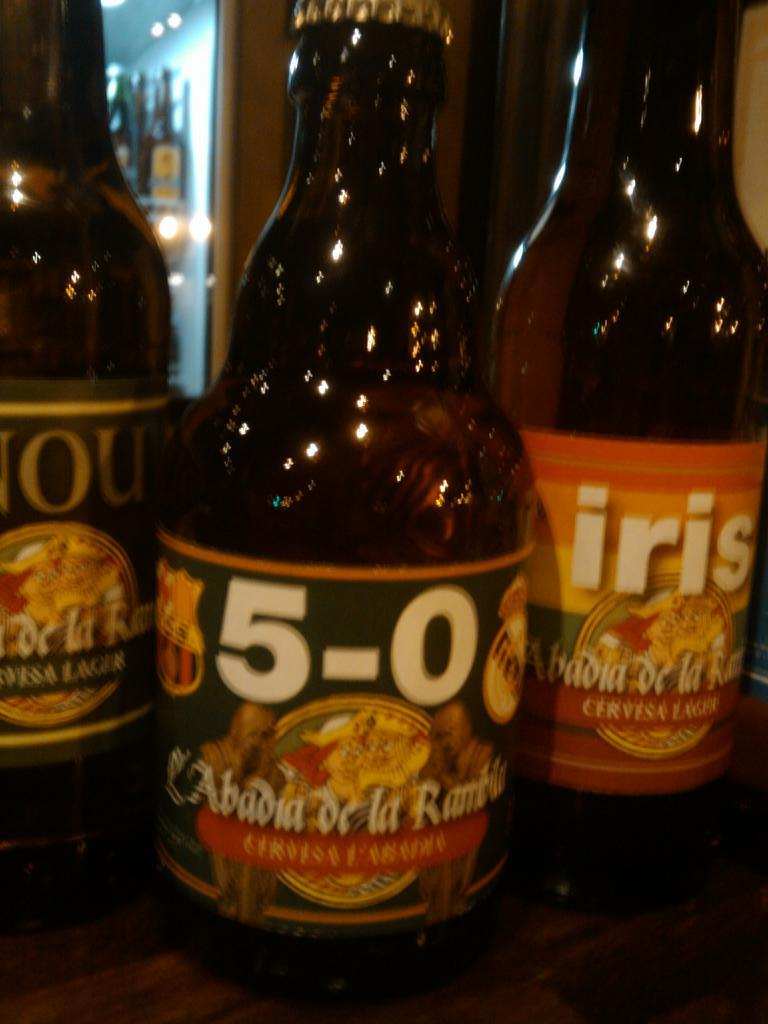<image>
Share a concise interpretation of the image provided. A bottle of Iris beer sits on a table to the right of two other beers from the same brand. 